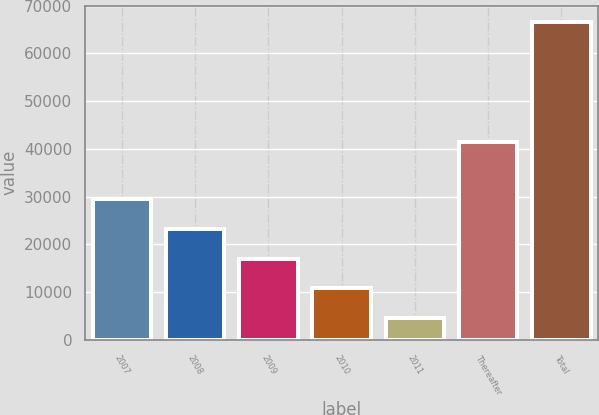Convert chart. <chart><loc_0><loc_0><loc_500><loc_500><bar_chart><fcel>2007<fcel>2008<fcel>2009<fcel>2010<fcel>2011<fcel>Thereafter<fcel>Total<nl><fcel>29449.6<fcel>23246.2<fcel>17042.8<fcel>10839.4<fcel>4636<fcel>41511<fcel>66670<nl></chart> 